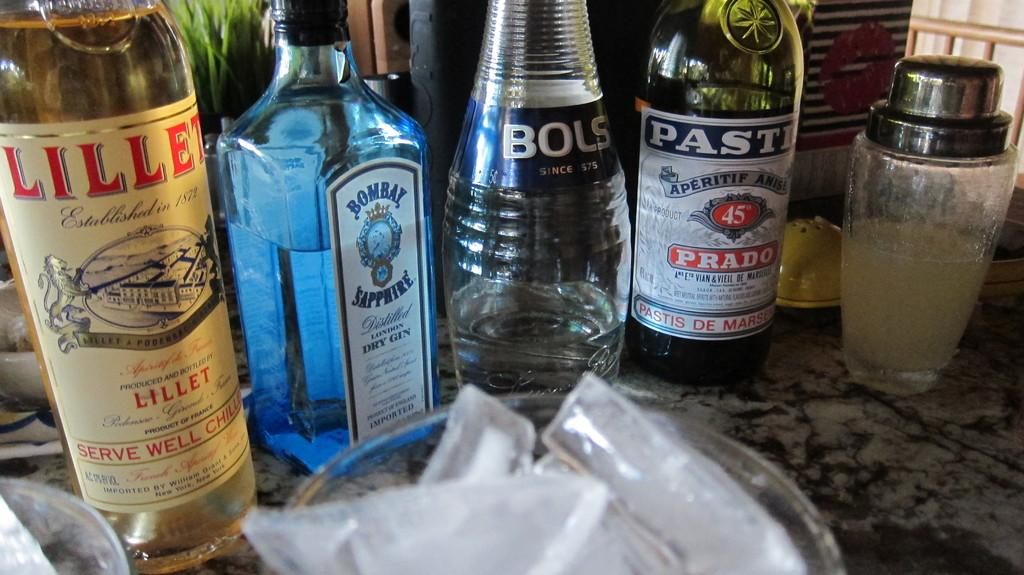<image>
Share a concise interpretation of the image provided. A bottle of Bombay Sapphire gin is surrounded by other bottles. 